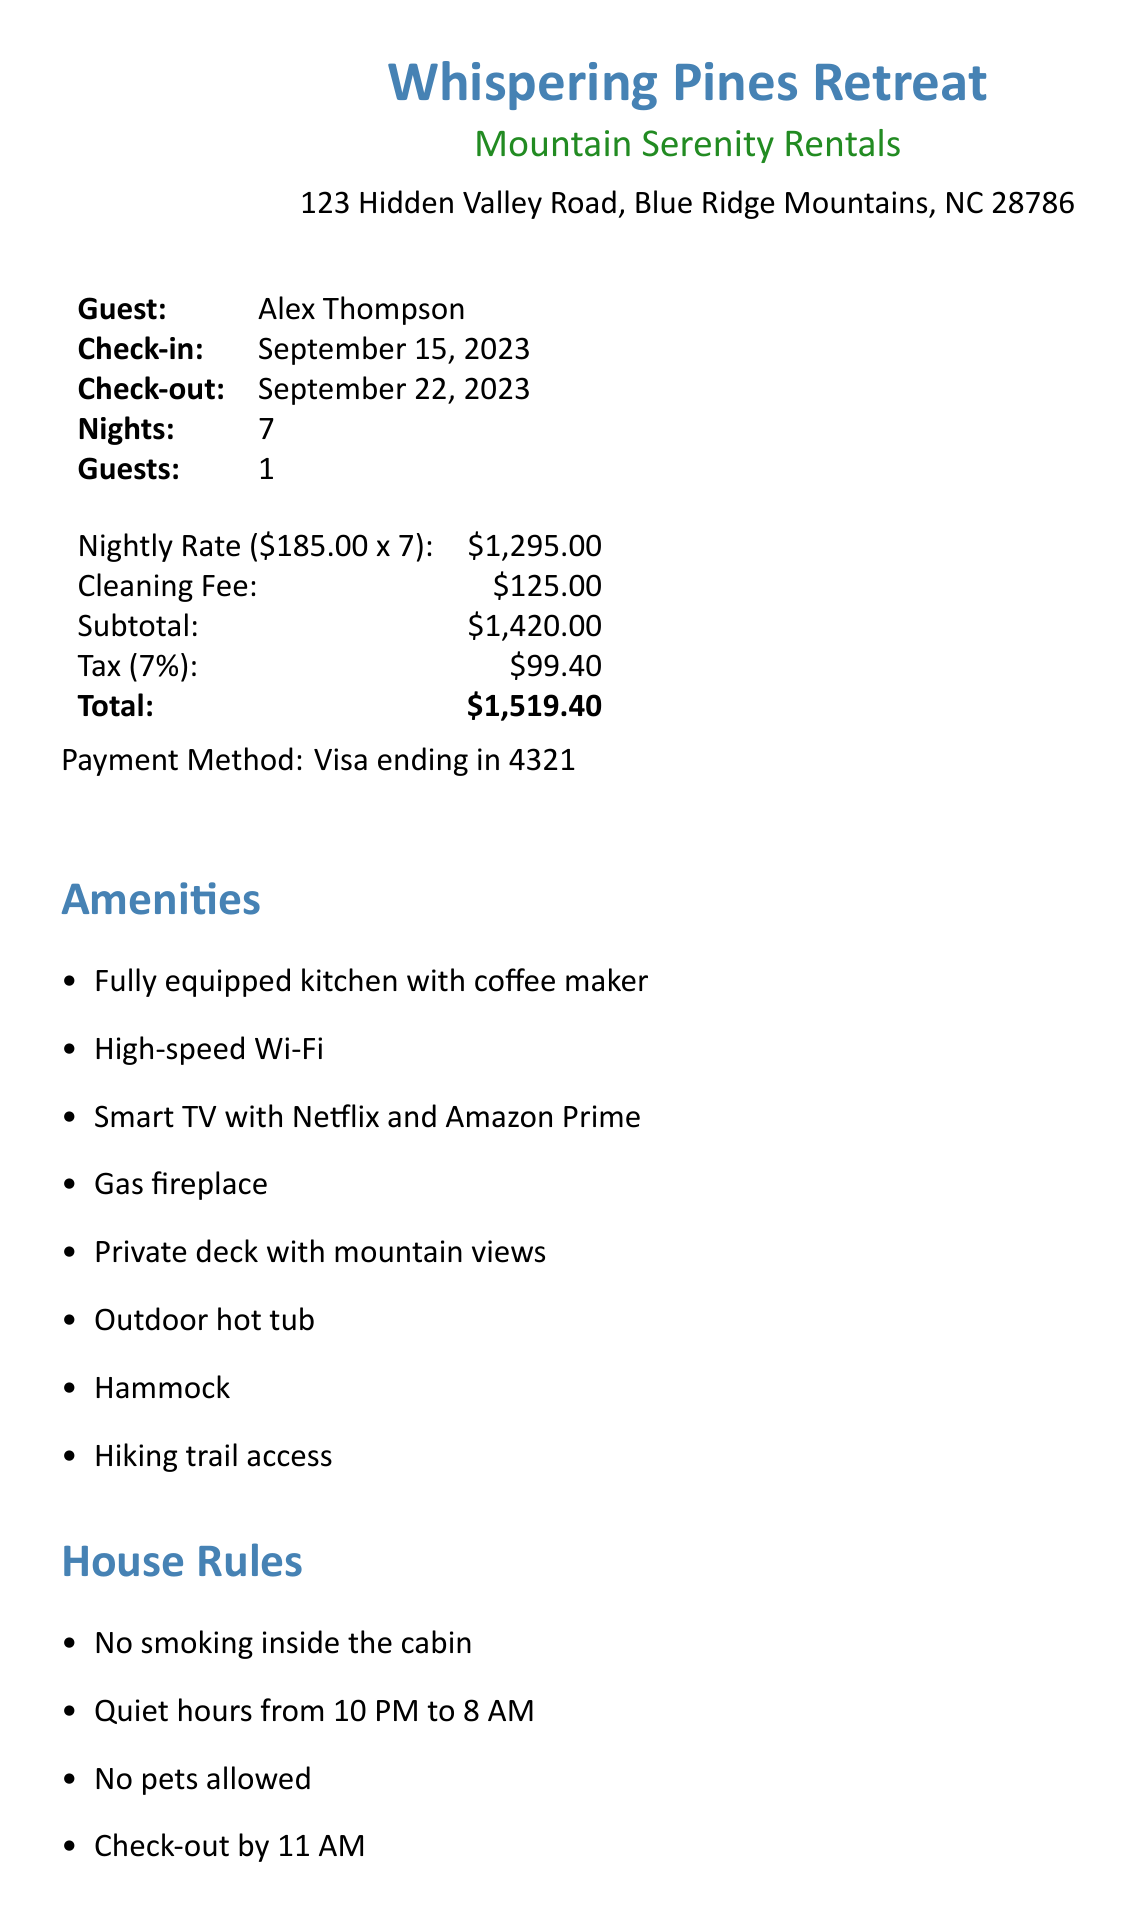What is the rental company name? The rental company is listed as Mountain Serenity Rentals in the document.
Answer: Mountain Serenity Rentals How many guests are allowed? The document states the number of guests allowed, which is one in this case.
Answer: 1 What is the nightly rate? The nightly rate is specified in the document as part of the pricing details.
Answer: $185.00 What is the cleaning fee? The cleaning fee is explicitly mentioned in the document.
Answer: $125.00 What is the total amount for the stay? The total amount is the grand total which includes all fees, as shown in the document.
Answer: $1,519.40 What are the check-in and check-out dates? The document provides the check-in and check-out dates, which are specifically mentioned.
Answer: September 15, 2023 and September 22, 2023 What amenities are included? The document lists various amenities that are part of the cabin's offerings, which can be found under the 'Amenities' section.
Answer: Fully equipped kitchen with coffee maker, High-speed Wi-Fi, Smart TV with Netflix and Amazon Prime, Gas fireplace, Private deck with mountain views, Outdoor hot tub, Hammock, Hiking trail access What is the cancellation policy? The cancellation policy outlines the terms for refunds, as described in the document.
Answer: Full refund if cancelled 14 days before check-in, 50% refund if cancelled 7 days before check-in What is the emergency contact information? The document specifies the emergency contact name and phone number for assistance during the stay.
Answer: Mountain Serenity Rentals Office (828-555-1234) 